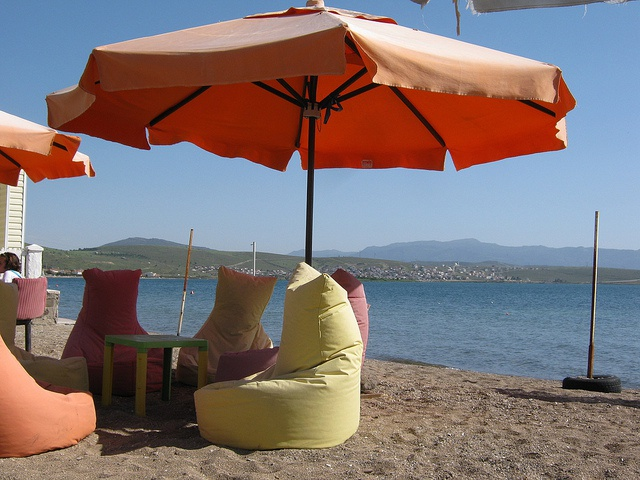Describe the objects in this image and their specific colors. I can see umbrella in gray, maroon, tan, and white tones, chair in gray, olive, khaki, and tan tones, chair in gray, salmon, maroon, and brown tones, chair in gray, black, maroon, and purple tones, and chair in gray, maroon, and black tones in this image. 